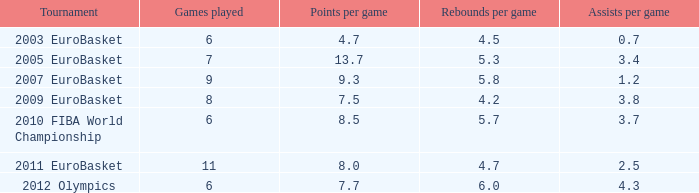What is the number of games with an average of 4.7 points per game? 1.0. 